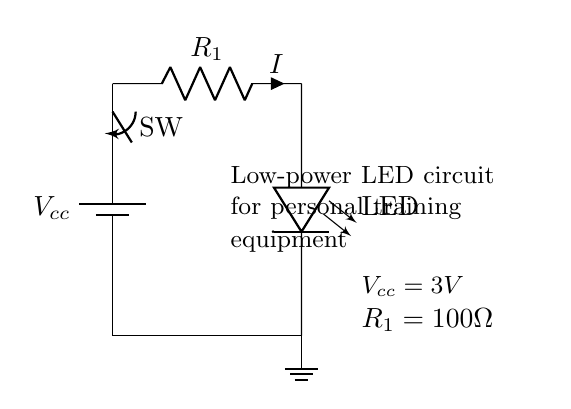What is the value of the power supply voltage? The circuit indicates that the power supply voltage is labeled as Vcc, with a specified value of 3 volts.
Answer: 3 volts What type of switch is used in this circuit? The component labeled as "SW" indicates that a switch is present in the circuit, specifically a standard mechanical switch allowing for manual operation.
Answer: Mechanical switch What is the purpose of resistor R1? The resistor R1 is used as a current limiting resistor, which is critical in controlling the current through the LED to prevent it from burning out.
Answer: Current limiting What is the resistance value of R1? The resistance value is specified next to R1 in the circuit diagram and is given as 100 ohms.
Answer: 100 ohms How many components are in this circuit? By counting the components shown—battery, switch, resistor, LED, and ground—the total is five distinct components in this circuit.
Answer: Five If the LED operates at 20 mA, is the selected resistor suitable? The current through the circuit can be calculated using Ohm's Law with the voltage and resistance values. Using 3V and 100 ohms, the current I = V/R = 3V/100 ohms = 0.03 A or 30 mA. Since this exceeds the LED's specified operating current of 20 mA, the resistor is not suitable without modification.
Answer: No What is the type of load connected in this circuit? The load in this circuit is an LED, which signifies that the circuit is designed to produce light upon activation.
Answer: LED 